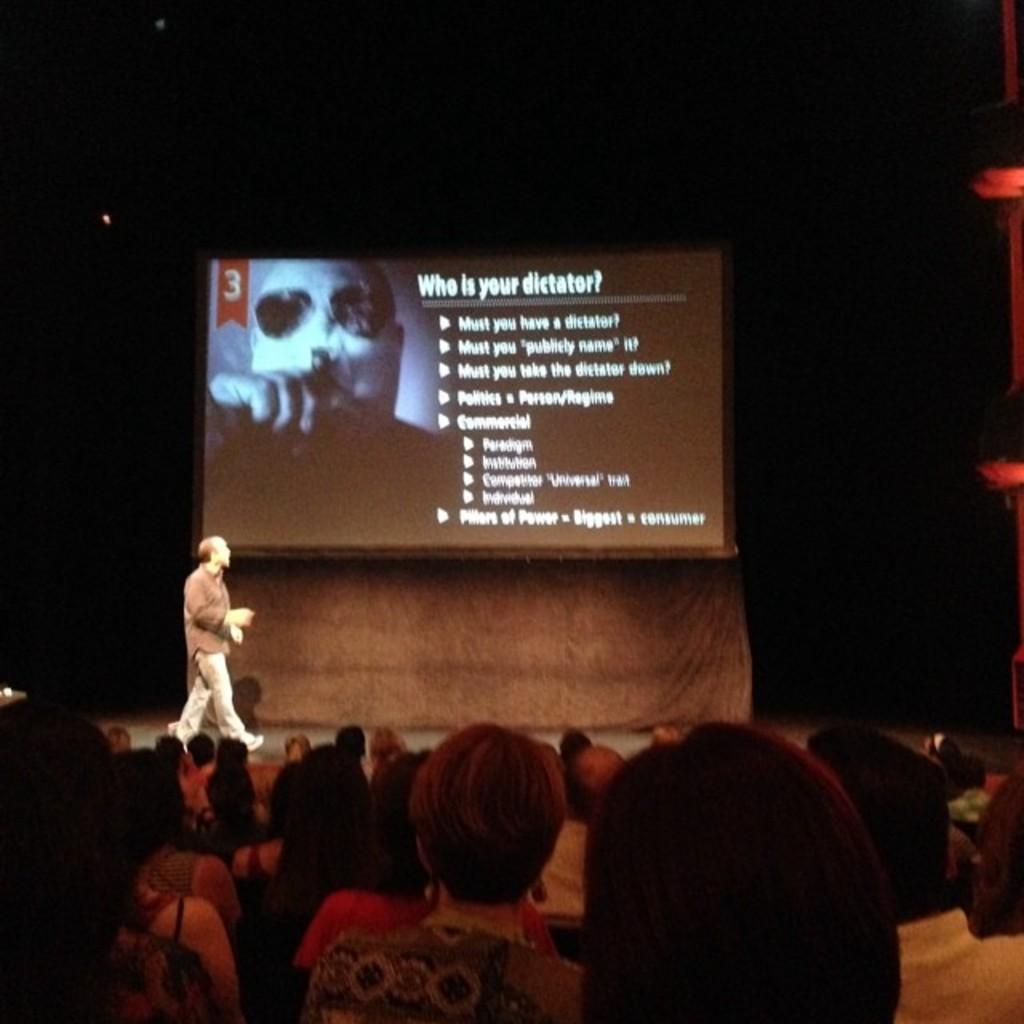Please provide a concise description of this image. In this image I can see number of people where one is standing and rest all are sitting. In the background I can see a screen and on it I can see something is written. I can also see this image is little bit in dark. 